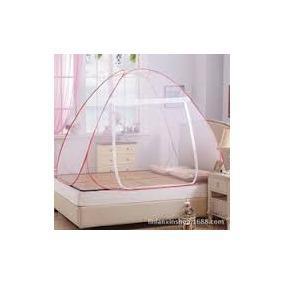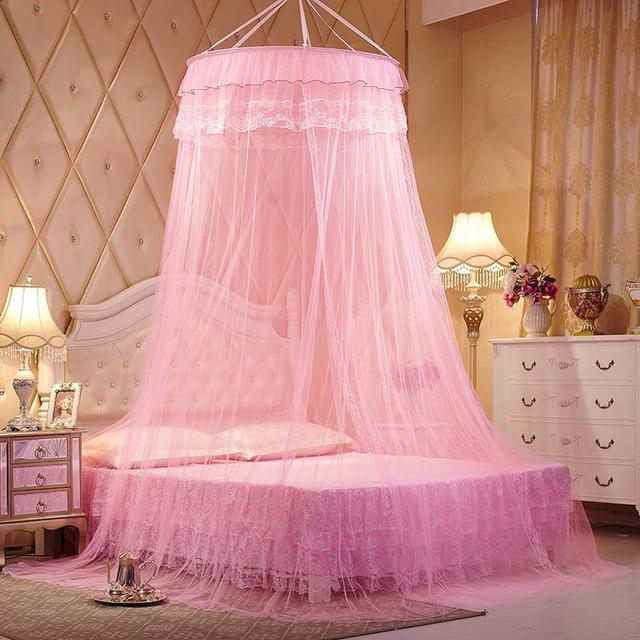The first image is the image on the left, the second image is the image on the right. Evaluate the accuracy of this statement regarding the images: "There is a round canopy bed in the right image.". Is it true? Answer yes or no. Yes. The first image is the image on the left, the second image is the image on the right. Analyze the images presented: Is the assertion "There are two canopies, one tent and one hanging from the ceiling." valid? Answer yes or no. Yes. 